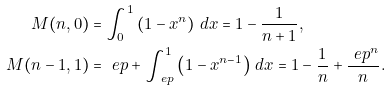<formula> <loc_0><loc_0><loc_500><loc_500>M ( n , 0 ) & = \int _ { 0 } ^ { 1 } \left ( 1 - x ^ { n } \right ) \, d x = 1 - \frac { 1 } { n + 1 } , \\ M ( n - 1 , 1 ) & = \ e p + \int _ { \ e p } ^ { 1 } \left ( 1 - x ^ { n - 1 } \right ) \, d x = 1 - \frac { 1 } { n } + \frac { \ e p ^ { n } } { n } .</formula> 